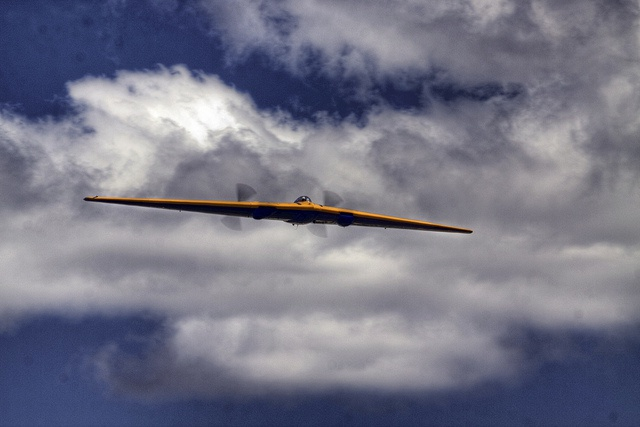Describe the objects in this image and their specific colors. I can see a airplane in navy, black, darkgray, orange, and gray tones in this image. 